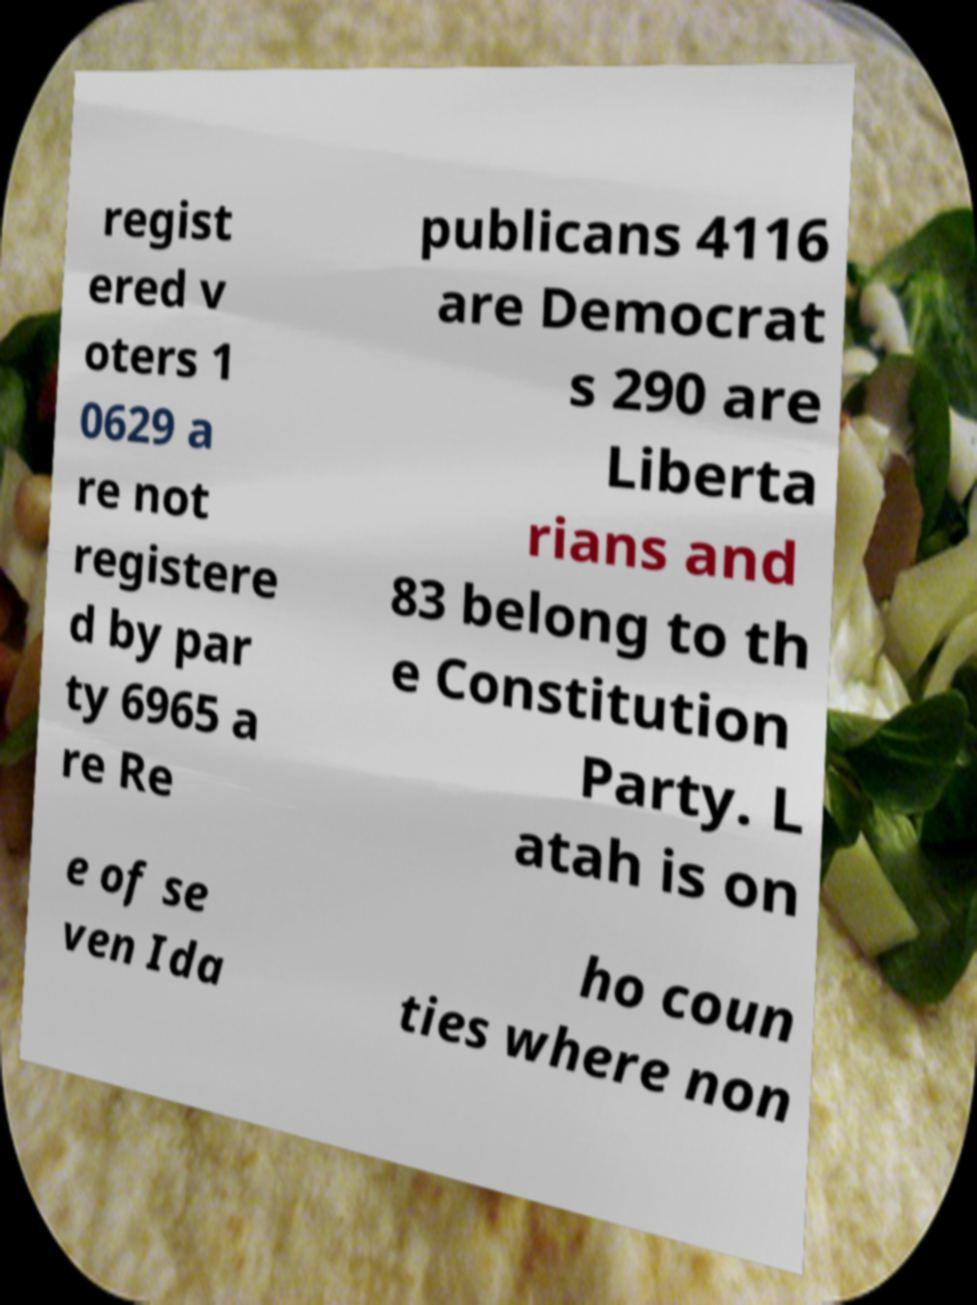Please read and relay the text visible in this image. What does it say? regist ered v oters 1 0629 a re not registere d by par ty 6965 a re Re publicans 4116 are Democrat s 290 are Liberta rians and 83 belong to th e Constitution Party. L atah is on e of se ven Ida ho coun ties where non 